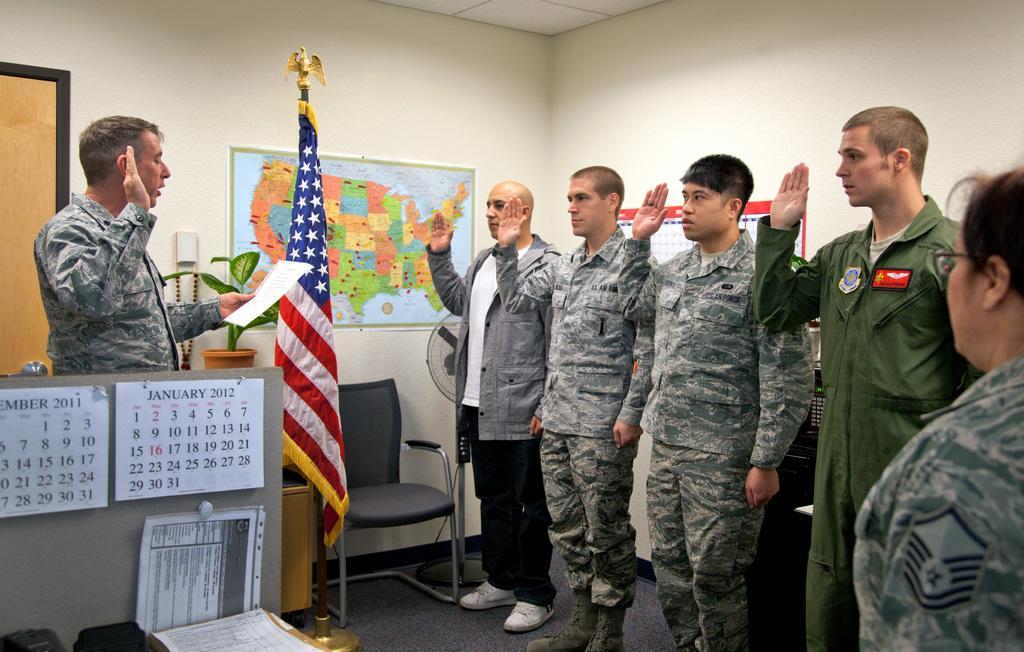How would you summarize this image in a sentence or two? In this picture I can see group of people standing and there is a man holding a paper. I can see a chair, flag, papers, plant, table fan and some other objects, and in the background there are boards attached to the walls. 